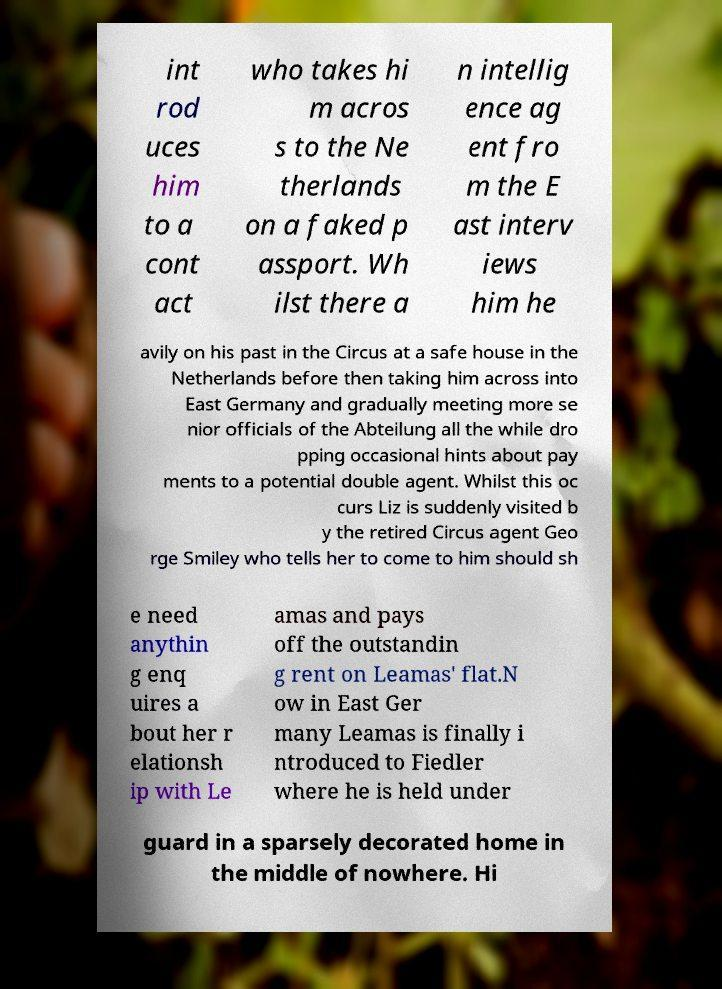For documentation purposes, I need the text within this image transcribed. Could you provide that? int rod uces him to a cont act who takes hi m acros s to the Ne therlands on a faked p assport. Wh ilst there a n intellig ence ag ent fro m the E ast interv iews him he avily on his past in the Circus at a safe house in the Netherlands before then taking him across into East Germany and gradually meeting more se nior officials of the Abteilung all the while dro pping occasional hints about pay ments to a potential double agent. Whilst this oc curs Liz is suddenly visited b y the retired Circus agent Geo rge Smiley who tells her to come to him should sh e need anythin g enq uires a bout her r elationsh ip with Le amas and pays off the outstandin g rent on Leamas' flat.N ow in East Ger many Leamas is finally i ntroduced to Fiedler where he is held under guard in a sparsely decorated home in the middle of nowhere. Hi 